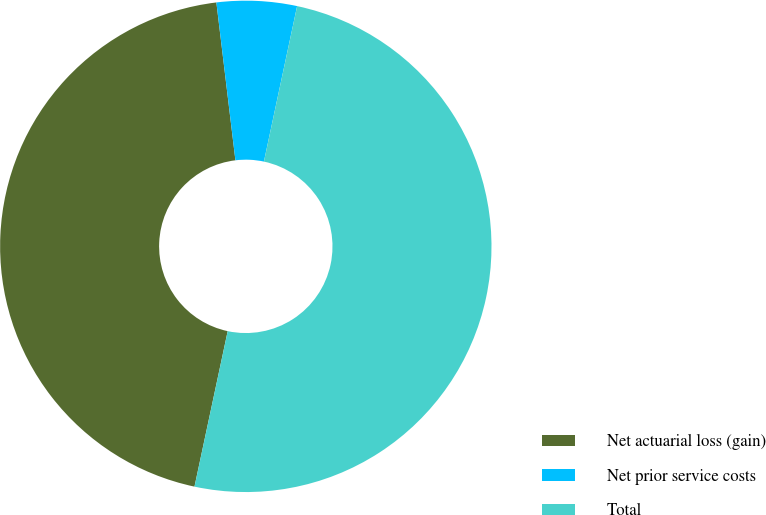<chart> <loc_0><loc_0><loc_500><loc_500><pie_chart><fcel>Net actuarial loss (gain)<fcel>Net prior service costs<fcel>Total<nl><fcel>44.74%<fcel>5.26%<fcel>50.0%<nl></chart> 